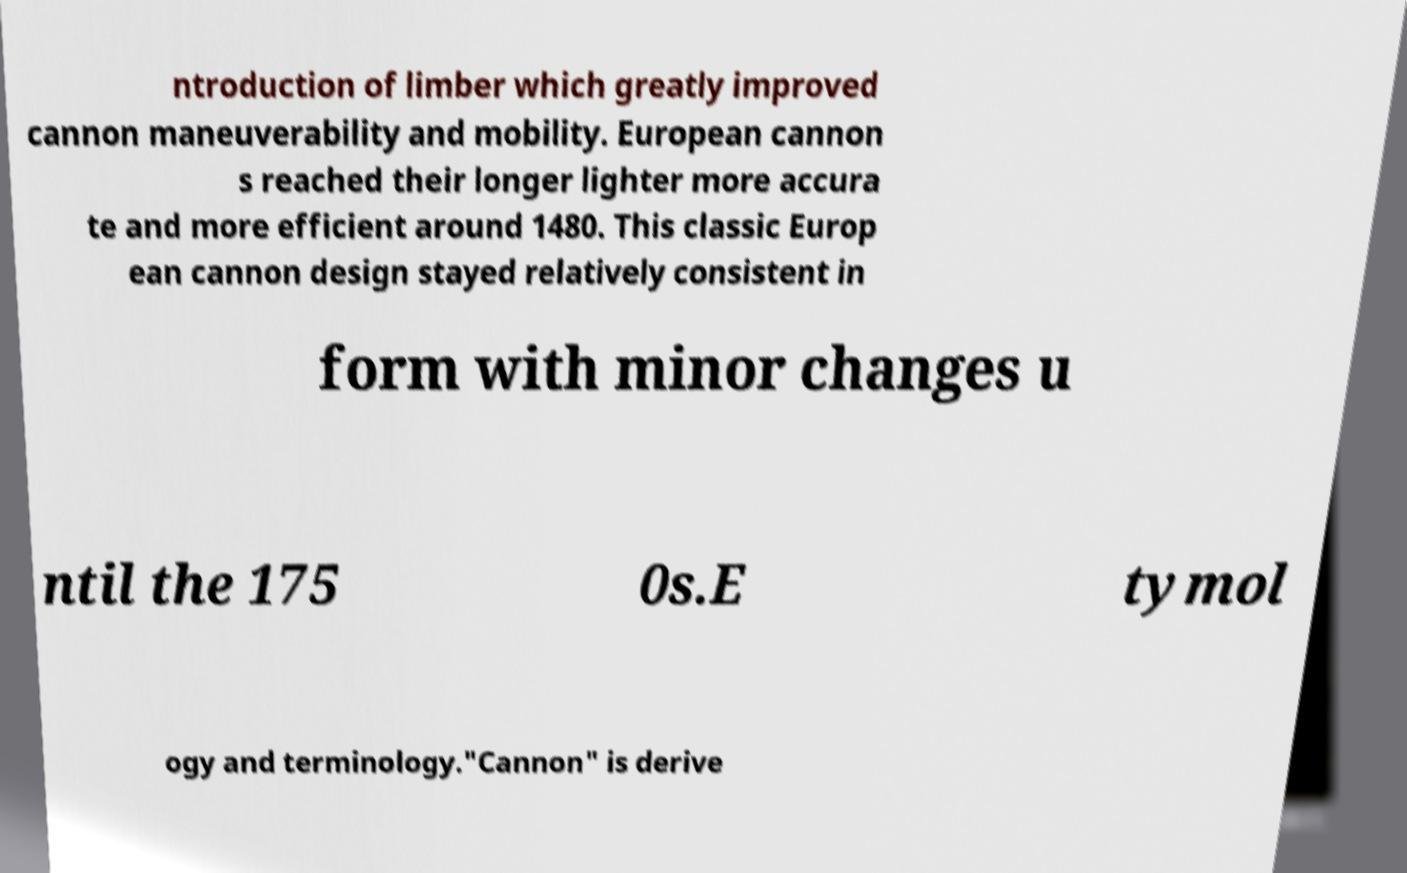What messages or text are displayed in this image? I need them in a readable, typed format. ntroduction of limber which greatly improved cannon maneuverability and mobility. European cannon s reached their longer lighter more accura te and more efficient around 1480. This classic Europ ean cannon design stayed relatively consistent in form with minor changes u ntil the 175 0s.E tymol ogy and terminology."Cannon" is derive 